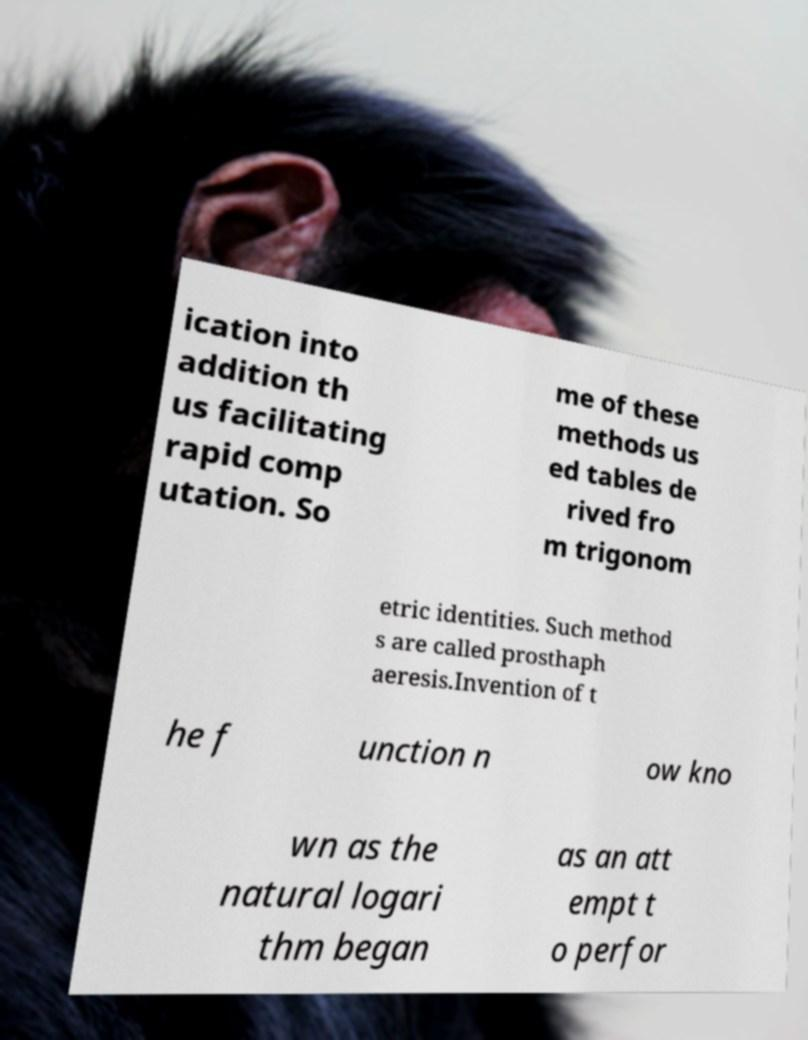Please read and relay the text visible in this image. What does it say? ication into addition th us facilitating rapid comp utation. So me of these methods us ed tables de rived fro m trigonom etric identities. Such method s are called prosthaph aeresis.Invention of t he f unction n ow kno wn as the natural logari thm began as an att empt t o perfor 